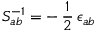Convert formula to latex. <formula><loc_0><loc_0><loc_500><loc_500>S _ { a b } ^ { - 1 } = - \, \frac { 1 } { 2 } \, \epsilon _ { a b }</formula> 